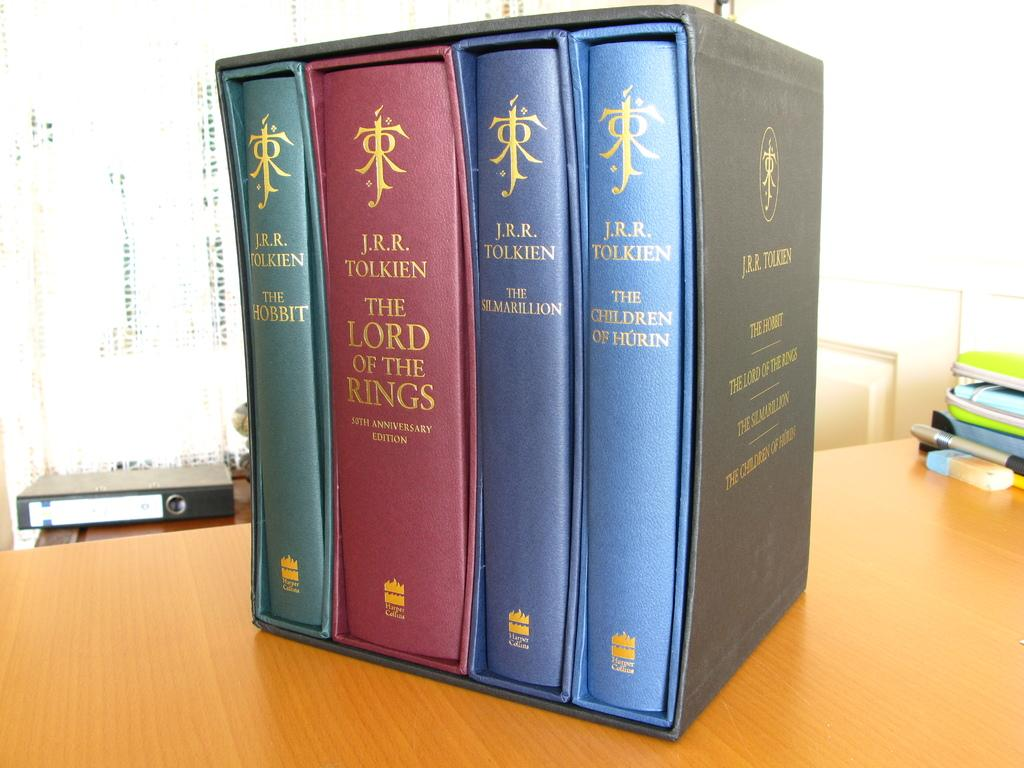<image>
Render a clear and concise summary of the photo. A four set of books, one of them being The Lord of the Rings. 